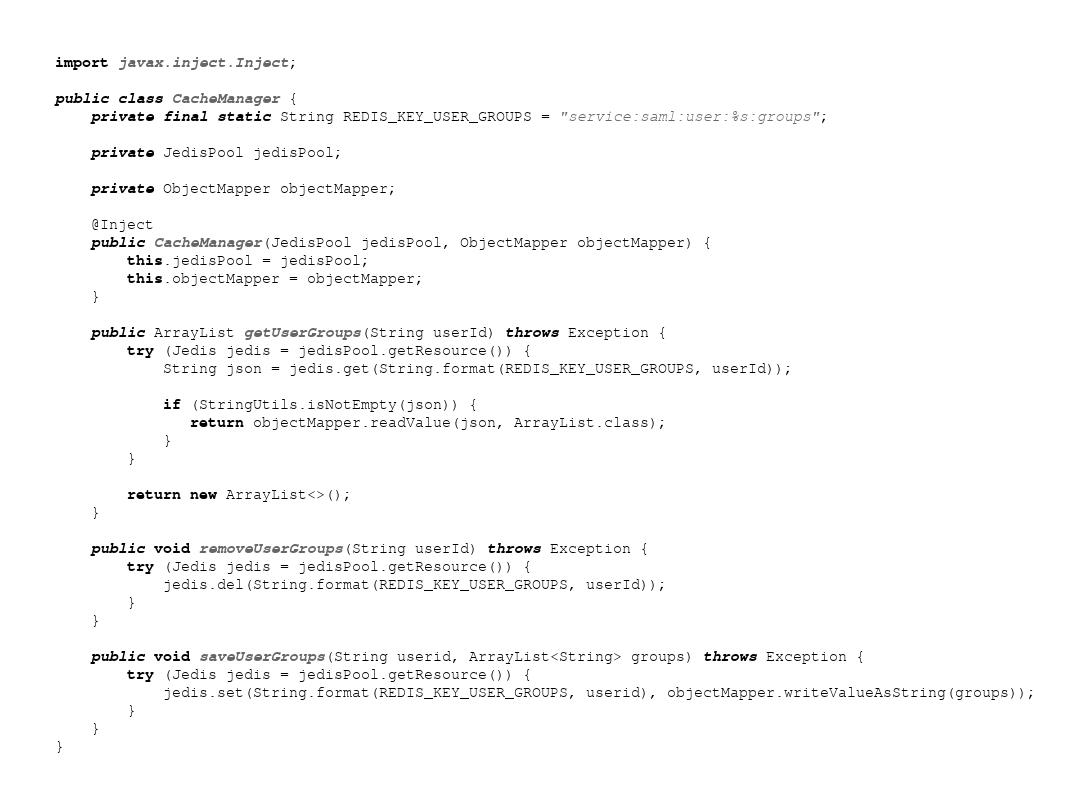Convert code to text. <code><loc_0><loc_0><loc_500><loc_500><_Java_>
import javax.inject.Inject;

public class CacheManager {
    private final static String REDIS_KEY_USER_GROUPS = "service:saml:user:%s:groups";

    private JedisPool jedisPool;

    private ObjectMapper objectMapper;

    @Inject
    public CacheManager(JedisPool jedisPool, ObjectMapper objectMapper) {
        this.jedisPool = jedisPool;
        this.objectMapper = objectMapper;
    }

    public ArrayList getUserGroups(String userId) throws Exception {
        try (Jedis jedis = jedisPool.getResource()) {
            String json = jedis.get(String.format(REDIS_KEY_USER_GROUPS, userId));

            if (StringUtils.isNotEmpty(json)) {
               return objectMapper.readValue(json, ArrayList.class);
            }
        }

        return new ArrayList<>();
    }

    public void removeUserGroups(String userId) throws Exception {
        try (Jedis jedis = jedisPool.getResource()) {
            jedis.del(String.format(REDIS_KEY_USER_GROUPS, userId));
        }
    }

    public void saveUserGroups(String userid, ArrayList<String> groups) throws Exception {
        try (Jedis jedis = jedisPool.getResource()) {
            jedis.set(String.format(REDIS_KEY_USER_GROUPS, userid), objectMapper.writeValueAsString(groups));
        }
    }
}
</code> 